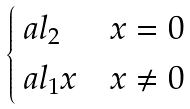<formula> <loc_0><loc_0><loc_500><loc_500>\begin{cases} \ a l _ { 2 } & x = 0 \\ \ a l _ { 1 } x & x \neq 0 \end{cases}</formula> 